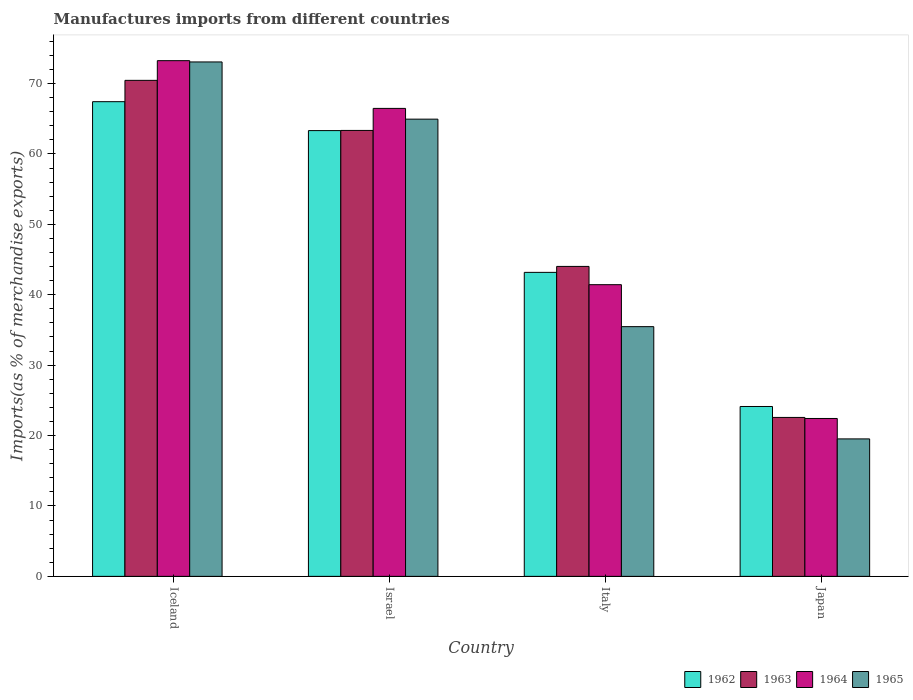How many different coloured bars are there?
Your response must be concise. 4. What is the percentage of imports to different countries in 1965 in Iceland?
Ensure brevity in your answer.  73.07. Across all countries, what is the maximum percentage of imports to different countries in 1963?
Your answer should be compact. 70.45. Across all countries, what is the minimum percentage of imports to different countries in 1964?
Offer a very short reply. 22.43. In which country was the percentage of imports to different countries in 1964 minimum?
Your answer should be compact. Japan. What is the total percentage of imports to different countries in 1964 in the graph?
Your response must be concise. 203.58. What is the difference between the percentage of imports to different countries in 1962 in Iceland and that in Israel?
Provide a short and direct response. 4.11. What is the difference between the percentage of imports to different countries in 1965 in Iceland and the percentage of imports to different countries in 1963 in Israel?
Your answer should be compact. 9.73. What is the average percentage of imports to different countries in 1963 per country?
Your answer should be compact. 50.1. What is the difference between the percentage of imports to different countries of/in 1962 and percentage of imports to different countries of/in 1964 in Iceland?
Keep it short and to the point. -5.83. In how many countries, is the percentage of imports to different countries in 1963 greater than 28 %?
Provide a succinct answer. 3. What is the ratio of the percentage of imports to different countries in 1964 in Iceland to that in Italy?
Offer a very short reply. 1.77. Is the difference between the percentage of imports to different countries in 1962 in Israel and Italy greater than the difference between the percentage of imports to different countries in 1964 in Israel and Italy?
Your response must be concise. No. What is the difference between the highest and the second highest percentage of imports to different countries in 1963?
Offer a terse response. -26.43. What is the difference between the highest and the lowest percentage of imports to different countries in 1965?
Ensure brevity in your answer.  53.54. What does the 2nd bar from the right in Japan represents?
Keep it short and to the point. 1964. Does the graph contain grids?
Offer a terse response. No. How many legend labels are there?
Your answer should be very brief. 4. What is the title of the graph?
Provide a succinct answer. Manufactures imports from different countries. Does "1971" appear as one of the legend labels in the graph?
Ensure brevity in your answer.  No. What is the label or title of the X-axis?
Offer a terse response. Country. What is the label or title of the Y-axis?
Your answer should be very brief. Imports(as % of merchandise exports). What is the Imports(as % of merchandise exports) of 1962 in Iceland?
Provide a succinct answer. 67.42. What is the Imports(as % of merchandise exports) in 1963 in Iceland?
Offer a terse response. 70.45. What is the Imports(as % of merchandise exports) in 1964 in Iceland?
Provide a short and direct response. 73.25. What is the Imports(as % of merchandise exports) of 1965 in Iceland?
Give a very brief answer. 73.07. What is the Imports(as % of merchandise exports) in 1962 in Israel?
Offer a terse response. 63.32. What is the Imports(as % of merchandise exports) of 1963 in Israel?
Provide a short and direct response. 63.34. What is the Imports(as % of merchandise exports) in 1964 in Israel?
Your answer should be compact. 66.47. What is the Imports(as % of merchandise exports) in 1965 in Israel?
Give a very brief answer. 64.94. What is the Imports(as % of merchandise exports) of 1962 in Italy?
Make the answer very short. 43.18. What is the Imports(as % of merchandise exports) in 1963 in Italy?
Offer a very short reply. 44.02. What is the Imports(as % of merchandise exports) in 1964 in Italy?
Give a very brief answer. 41.43. What is the Imports(as % of merchandise exports) in 1965 in Italy?
Give a very brief answer. 35.47. What is the Imports(as % of merchandise exports) in 1962 in Japan?
Offer a very short reply. 24.13. What is the Imports(as % of merchandise exports) of 1963 in Japan?
Offer a terse response. 22.57. What is the Imports(as % of merchandise exports) of 1964 in Japan?
Offer a very short reply. 22.43. What is the Imports(as % of merchandise exports) of 1965 in Japan?
Offer a terse response. 19.52. Across all countries, what is the maximum Imports(as % of merchandise exports) of 1962?
Keep it short and to the point. 67.42. Across all countries, what is the maximum Imports(as % of merchandise exports) in 1963?
Provide a succinct answer. 70.45. Across all countries, what is the maximum Imports(as % of merchandise exports) of 1964?
Provide a succinct answer. 73.25. Across all countries, what is the maximum Imports(as % of merchandise exports) in 1965?
Give a very brief answer. 73.07. Across all countries, what is the minimum Imports(as % of merchandise exports) in 1962?
Your answer should be compact. 24.13. Across all countries, what is the minimum Imports(as % of merchandise exports) of 1963?
Your answer should be compact. 22.57. Across all countries, what is the minimum Imports(as % of merchandise exports) of 1964?
Provide a succinct answer. 22.43. Across all countries, what is the minimum Imports(as % of merchandise exports) in 1965?
Keep it short and to the point. 19.52. What is the total Imports(as % of merchandise exports) in 1962 in the graph?
Provide a short and direct response. 198.05. What is the total Imports(as % of merchandise exports) in 1963 in the graph?
Ensure brevity in your answer.  200.39. What is the total Imports(as % of merchandise exports) in 1964 in the graph?
Offer a very short reply. 203.58. What is the total Imports(as % of merchandise exports) of 1965 in the graph?
Your response must be concise. 193. What is the difference between the Imports(as % of merchandise exports) of 1962 in Iceland and that in Israel?
Ensure brevity in your answer.  4.11. What is the difference between the Imports(as % of merchandise exports) in 1963 in Iceland and that in Israel?
Offer a very short reply. 7.11. What is the difference between the Imports(as % of merchandise exports) of 1964 in Iceland and that in Israel?
Provide a short and direct response. 6.78. What is the difference between the Imports(as % of merchandise exports) of 1965 in Iceland and that in Israel?
Provide a short and direct response. 8.12. What is the difference between the Imports(as % of merchandise exports) of 1962 in Iceland and that in Italy?
Keep it short and to the point. 24.24. What is the difference between the Imports(as % of merchandise exports) in 1963 in Iceland and that in Italy?
Ensure brevity in your answer.  26.43. What is the difference between the Imports(as % of merchandise exports) of 1964 in Iceland and that in Italy?
Keep it short and to the point. 31.82. What is the difference between the Imports(as % of merchandise exports) of 1965 in Iceland and that in Italy?
Offer a very short reply. 37.6. What is the difference between the Imports(as % of merchandise exports) in 1962 in Iceland and that in Japan?
Give a very brief answer. 43.29. What is the difference between the Imports(as % of merchandise exports) of 1963 in Iceland and that in Japan?
Provide a succinct answer. 47.88. What is the difference between the Imports(as % of merchandise exports) of 1964 in Iceland and that in Japan?
Your answer should be very brief. 50.82. What is the difference between the Imports(as % of merchandise exports) in 1965 in Iceland and that in Japan?
Your answer should be compact. 53.54. What is the difference between the Imports(as % of merchandise exports) of 1962 in Israel and that in Italy?
Offer a very short reply. 20.14. What is the difference between the Imports(as % of merchandise exports) of 1963 in Israel and that in Italy?
Make the answer very short. 19.32. What is the difference between the Imports(as % of merchandise exports) in 1964 in Israel and that in Italy?
Ensure brevity in your answer.  25.04. What is the difference between the Imports(as % of merchandise exports) of 1965 in Israel and that in Italy?
Keep it short and to the point. 29.47. What is the difference between the Imports(as % of merchandise exports) in 1962 in Israel and that in Japan?
Offer a very short reply. 39.19. What is the difference between the Imports(as % of merchandise exports) of 1963 in Israel and that in Japan?
Your response must be concise. 40.77. What is the difference between the Imports(as % of merchandise exports) of 1964 in Israel and that in Japan?
Offer a very short reply. 44.04. What is the difference between the Imports(as % of merchandise exports) of 1965 in Israel and that in Japan?
Make the answer very short. 45.42. What is the difference between the Imports(as % of merchandise exports) in 1962 in Italy and that in Japan?
Your answer should be very brief. 19.05. What is the difference between the Imports(as % of merchandise exports) of 1963 in Italy and that in Japan?
Provide a short and direct response. 21.45. What is the difference between the Imports(as % of merchandise exports) of 1964 in Italy and that in Japan?
Provide a short and direct response. 19. What is the difference between the Imports(as % of merchandise exports) of 1965 in Italy and that in Japan?
Give a very brief answer. 15.94. What is the difference between the Imports(as % of merchandise exports) in 1962 in Iceland and the Imports(as % of merchandise exports) in 1963 in Israel?
Offer a terse response. 4.08. What is the difference between the Imports(as % of merchandise exports) in 1962 in Iceland and the Imports(as % of merchandise exports) in 1964 in Israel?
Offer a very short reply. 0.95. What is the difference between the Imports(as % of merchandise exports) of 1962 in Iceland and the Imports(as % of merchandise exports) of 1965 in Israel?
Your answer should be very brief. 2.48. What is the difference between the Imports(as % of merchandise exports) of 1963 in Iceland and the Imports(as % of merchandise exports) of 1964 in Israel?
Your response must be concise. 3.98. What is the difference between the Imports(as % of merchandise exports) in 1963 in Iceland and the Imports(as % of merchandise exports) in 1965 in Israel?
Your answer should be very brief. 5.51. What is the difference between the Imports(as % of merchandise exports) of 1964 in Iceland and the Imports(as % of merchandise exports) of 1965 in Israel?
Give a very brief answer. 8.31. What is the difference between the Imports(as % of merchandise exports) in 1962 in Iceland and the Imports(as % of merchandise exports) in 1963 in Italy?
Offer a terse response. 23.4. What is the difference between the Imports(as % of merchandise exports) of 1962 in Iceland and the Imports(as % of merchandise exports) of 1964 in Italy?
Your response must be concise. 25.99. What is the difference between the Imports(as % of merchandise exports) of 1962 in Iceland and the Imports(as % of merchandise exports) of 1965 in Italy?
Give a very brief answer. 31.95. What is the difference between the Imports(as % of merchandise exports) in 1963 in Iceland and the Imports(as % of merchandise exports) in 1964 in Italy?
Keep it short and to the point. 29.02. What is the difference between the Imports(as % of merchandise exports) of 1963 in Iceland and the Imports(as % of merchandise exports) of 1965 in Italy?
Ensure brevity in your answer.  34.99. What is the difference between the Imports(as % of merchandise exports) of 1964 in Iceland and the Imports(as % of merchandise exports) of 1965 in Italy?
Offer a very short reply. 37.78. What is the difference between the Imports(as % of merchandise exports) in 1962 in Iceland and the Imports(as % of merchandise exports) in 1963 in Japan?
Keep it short and to the point. 44.85. What is the difference between the Imports(as % of merchandise exports) of 1962 in Iceland and the Imports(as % of merchandise exports) of 1964 in Japan?
Provide a succinct answer. 45. What is the difference between the Imports(as % of merchandise exports) of 1962 in Iceland and the Imports(as % of merchandise exports) of 1965 in Japan?
Your answer should be compact. 47.9. What is the difference between the Imports(as % of merchandise exports) in 1963 in Iceland and the Imports(as % of merchandise exports) in 1964 in Japan?
Keep it short and to the point. 48.03. What is the difference between the Imports(as % of merchandise exports) of 1963 in Iceland and the Imports(as % of merchandise exports) of 1965 in Japan?
Provide a succinct answer. 50.93. What is the difference between the Imports(as % of merchandise exports) in 1964 in Iceland and the Imports(as % of merchandise exports) in 1965 in Japan?
Provide a succinct answer. 53.73. What is the difference between the Imports(as % of merchandise exports) in 1962 in Israel and the Imports(as % of merchandise exports) in 1963 in Italy?
Give a very brief answer. 19.29. What is the difference between the Imports(as % of merchandise exports) in 1962 in Israel and the Imports(as % of merchandise exports) in 1964 in Italy?
Make the answer very short. 21.88. What is the difference between the Imports(as % of merchandise exports) in 1962 in Israel and the Imports(as % of merchandise exports) in 1965 in Italy?
Your answer should be compact. 27.85. What is the difference between the Imports(as % of merchandise exports) in 1963 in Israel and the Imports(as % of merchandise exports) in 1964 in Italy?
Offer a terse response. 21.91. What is the difference between the Imports(as % of merchandise exports) of 1963 in Israel and the Imports(as % of merchandise exports) of 1965 in Italy?
Give a very brief answer. 27.87. What is the difference between the Imports(as % of merchandise exports) in 1964 in Israel and the Imports(as % of merchandise exports) in 1965 in Italy?
Your answer should be very brief. 31. What is the difference between the Imports(as % of merchandise exports) of 1962 in Israel and the Imports(as % of merchandise exports) of 1963 in Japan?
Your answer should be compact. 40.74. What is the difference between the Imports(as % of merchandise exports) in 1962 in Israel and the Imports(as % of merchandise exports) in 1964 in Japan?
Provide a short and direct response. 40.89. What is the difference between the Imports(as % of merchandise exports) in 1962 in Israel and the Imports(as % of merchandise exports) in 1965 in Japan?
Your answer should be very brief. 43.79. What is the difference between the Imports(as % of merchandise exports) in 1963 in Israel and the Imports(as % of merchandise exports) in 1964 in Japan?
Make the answer very short. 40.91. What is the difference between the Imports(as % of merchandise exports) in 1963 in Israel and the Imports(as % of merchandise exports) in 1965 in Japan?
Make the answer very short. 43.82. What is the difference between the Imports(as % of merchandise exports) in 1964 in Israel and the Imports(as % of merchandise exports) in 1965 in Japan?
Provide a short and direct response. 46.94. What is the difference between the Imports(as % of merchandise exports) in 1962 in Italy and the Imports(as % of merchandise exports) in 1963 in Japan?
Give a very brief answer. 20.61. What is the difference between the Imports(as % of merchandise exports) of 1962 in Italy and the Imports(as % of merchandise exports) of 1964 in Japan?
Your response must be concise. 20.75. What is the difference between the Imports(as % of merchandise exports) in 1962 in Italy and the Imports(as % of merchandise exports) in 1965 in Japan?
Provide a short and direct response. 23.66. What is the difference between the Imports(as % of merchandise exports) of 1963 in Italy and the Imports(as % of merchandise exports) of 1964 in Japan?
Your answer should be very brief. 21.6. What is the difference between the Imports(as % of merchandise exports) in 1963 in Italy and the Imports(as % of merchandise exports) in 1965 in Japan?
Offer a terse response. 24.5. What is the difference between the Imports(as % of merchandise exports) in 1964 in Italy and the Imports(as % of merchandise exports) in 1965 in Japan?
Offer a terse response. 21.91. What is the average Imports(as % of merchandise exports) of 1962 per country?
Your answer should be very brief. 49.51. What is the average Imports(as % of merchandise exports) in 1963 per country?
Offer a terse response. 50.1. What is the average Imports(as % of merchandise exports) of 1964 per country?
Give a very brief answer. 50.89. What is the average Imports(as % of merchandise exports) of 1965 per country?
Your answer should be very brief. 48.25. What is the difference between the Imports(as % of merchandise exports) of 1962 and Imports(as % of merchandise exports) of 1963 in Iceland?
Your response must be concise. -3.03. What is the difference between the Imports(as % of merchandise exports) in 1962 and Imports(as % of merchandise exports) in 1964 in Iceland?
Your answer should be compact. -5.83. What is the difference between the Imports(as % of merchandise exports) in 1962 and Imports(as % of merchandise exports) in 1965 in Iceland?
Provide a short and direct response. -5.64. What is the difference between the Imports(as % of merchandise exports) of 1963 and Imports(as % of merchandise exports) of 1964 in Iceland?
Keep it short and to the point. -2.8. What is the difference between the Imports(as % of merchandise exports) of 1963 and Imports(as % of merchandise exports) of 1965 in Iceland?
Your response must be concise. -2.61. What is the difference between the Imports(as % of merchandise exports) of 1964 and Imports(as % of merchandise exports) of 1965 in Iceland?
Ensure brevity in your answer.  0.18. What is the difference between the Imports(as % of merchandise exports) in 1962 and Imports(as % of merchandise exports) in 1963 in Israel?
Offer a terse response. -0.02. What is the difference between the Imports(as % of merchandise exports) of 1962 and Imports(as % of merchandise exports) of 1964 in Israel?
Provide a succinct answer. -3.15. What is the difference between the Imports(as % of merchandise exports) in 1962 and Imports(as % of merchandise exports) in 1965 in Israel?
Keep it short and to the point. -1.63. What is the difference between the Imports(as % of merchandise exports) of 1963 and Imports(as % of merchandise exports) of 1964 in Israel?
Keep it short and to the point. -3.13. What is the difference between the Imports(as % of merchandise exports) of 1963 and Imports(as % of merchandise exports) of 1965 in Israel?
Ensure brevity in your answer.  -1.6. What is the difference between the Imports(as % of merchandise exports) in 1964 and Imports(as % of merchandise exports) in 1965 in Israel?
Your response must be concise. 1.53. What is the difference between the Imports(as % of merchandise exports) of 1962 and Imports(as % of merchandise exports) of 1963 in Italy?
Keep it short and to the point. -0.84. What is the difference between the Imports(as % of merchandise exports) in 1962 and Imports(as % of merchandise exports) in 1964 in Italy?
Offer a very short reply. 1.75. What is the difference between the Imports(as % of merchandise exports) in 1962 and Imports(as % of merchandise exports) in 1965 in Italy?
Make the answer very short. 7.71. What is the difference between the Imports(as % of merchandise exports) in 1963 and Imports(as % of merchandise exports) in 1964 in Italy?
Your response must be concise. 2.59. What is the difference between the Imports(as % of merchandise exports) of 1963 and Imports(as % of merchandise exports) of 1965 in Italy?
Your answer should be compact. 8.56. What is the difference between the Imports(as % of merchandise exports) of 1964 and Imports(as % of merchandise exports) of 1965 in Italy?
Provide a short and direct response. 5.96. What is the difference between the Imports(as % of merchandise exports) in 1962 and Imports(as % of merchandise exports) in 1963 in Japan?
Provide a short and direct response. 1.55. What is the difference between the Imports(as % of merchandise exports) of 1962 and Imports(as % of merchandise exports) of 1964 in Japan?
Make the answer very short. 1.7. What is the difference between the Imports(as % of merchandise exports) of 1962 and Imports(as % of merchandise exports) of 1965 in Japan?
Your answer should be compact. 4.6. What is the difference between the Imports(as % of merchandise exports) of 1963 and Imports(as % of merchandise exports) of 1964 in Japan?
Your answer should be compact. 0.15. What is the difference between the Imports(as % of merchandise exports) of 1963 and Imports(as % of merchandise exports) of 1965 in Japan?
Offer a very short reply. 3.05. What is the difference between the Imports(as % of merchandise exports) in 1964 and Imports(as % of merchandise exports) in 1965 in Japan?
Give a very brief answer. 2.9. What is the ratio of the Imports(as % of merchandise exports) of 1962 in Iceland to that in Israel?
Your answer should be very brief. 1.06. What is the ratio of the Imports(as % of merchandise exports) of 1963 in Iceland to that in Israel?
Your response must be concise. 1.11. What is the ratio of the Imports(as % of merchandise exports) of 1964 in Iceland to that in Israel?
Give a very brief answer. 1.1. What is the ratio of the Imports(as % of merchandise exports) of 1965 in Iceland to that in Israel?
Provide a short and direct response. 1.13. What is the ratio of the Imports(as % of merchandise exports) of 1962 in Iceland to that in Italy?
Provide a succinct answer. 1.56. What is the ratio of the Imports(as % of merchandise exports) in 1963 in Iceland to that in Italy?
Provide a short and direct response. 1.6. What is the ratio of the Imports(as % of merchandise exports) in 1964 in Iceland to that in Italy?
Provide a short and direct response. 1.77. What is the ratio of the Imports(as % of merchandise exports) in 1965 in Iceland to that in Italy?
Your response must be concise. 2.06. What is the ratio of the Imports(as % of merchandise exports) in 1962 in Iceland to that in Japan?
Provide a short and direct response. 2.79. What is the ratio of the Imports(as % of merchandise exports) of 1963 in Iceland to that in Japan?
Provide a succinct answer. 3.12. What is the ratio of the Imports(as % of merchandise exports) of 1964 in Iceland to that in Japan?
Ensure brevity in your answer.  3.27. What is the ratio of the Imports(as % of merchandise exports) in 1965 in Iceland to that in Japan?
Your answer should be very brief. 3.74. What is the ratio of the Imports(as % of merchandise exports) of 1962 in Israel to that in Italy?
Give a very brief answer. 1.47. What is the ratio of the Imports(as % of merchandise exports) in 1963 in Israel to that in Italy?
Give a very brief answer. 1.44. What is the ratio of the Imports(as % of merchandise exports) of 1964 in Israel to that in Italy?
Provide a short and direct response. 1.6. What is the ratio of the Imports(as % of merchandise exports) of 1965 in Israel to that in Italy?
Provide a succinct answer. 1.83. What is the ratio of the Imports(as % of merchandise exports) in 1962 in Israel to that in Japan?
Make the answer very short. 2.62. What is the ratio of the Imports(as % of merchandise exports) in 1963 in Israel to that in Japan?
Keep it short and to the point. 2.81. What is the ratio of the Imports(as % of merchandise exports) of 1964 in Israel to that in Japan?
Offer a terse response. 2.96. What is the ratio of the Imports(as % of merchandise exports) in 1965 in Israel to that in Japan?
Ensure brevity in your answer.  3.33. What is the ratio of the Imports(as % of merchandise exports) of 1962 in Italy to that in Japan?
Keep it short and to the point. 1.79. What is the ratio of the Imports(as % of merchandise exports) in 1963 in Italy to that in Japan?
Your response must be concise. 1.95. What is the ratio of the Imports(as % of merchandise exports) of 1964 in Italy to that in Japan?
Your response must be concise. 1.85. What is the ratio of the Imports(as % of merchandise exports) of 1965 in Italy to that in Japan?
Your answer should be compact. 1.82. What is the difference between the highest and the second highest Imports(as % of merchandise exports) of 1962?
Keep it short and to the point. 4.11. What is the difference between the highest and the second highest Imports(as % of merchandise exports) of 1963?
Offer a very short reply. 7.11. What is the difference between the highest and the second highest Imports(as % of merchandise exports) in 1964?
Give a very brief answer. 6.78. What is the difference between the highest and the second highest Imports(as % of merchandise exports) in 1965?
Your answer should be compact. 8.12. What is the difference between the highest and the lowest Imports(as % of merchandise exports) in 1962?
Your answer should be very brief. 43.29. What is the difference between the highest and the lowest Imports(as % of merchandise exports) in 1963?
Make the answer very short. 47.88. What is the difference between the highest and the lowest Imports(as % of merchandise exports) of 1964?
Your answer should be compact. 50.82. What is the difference between the highest and the lowest Imports(as % of merchandise exports) of 1965?
Ensure brevity in your answer.  53.54. 